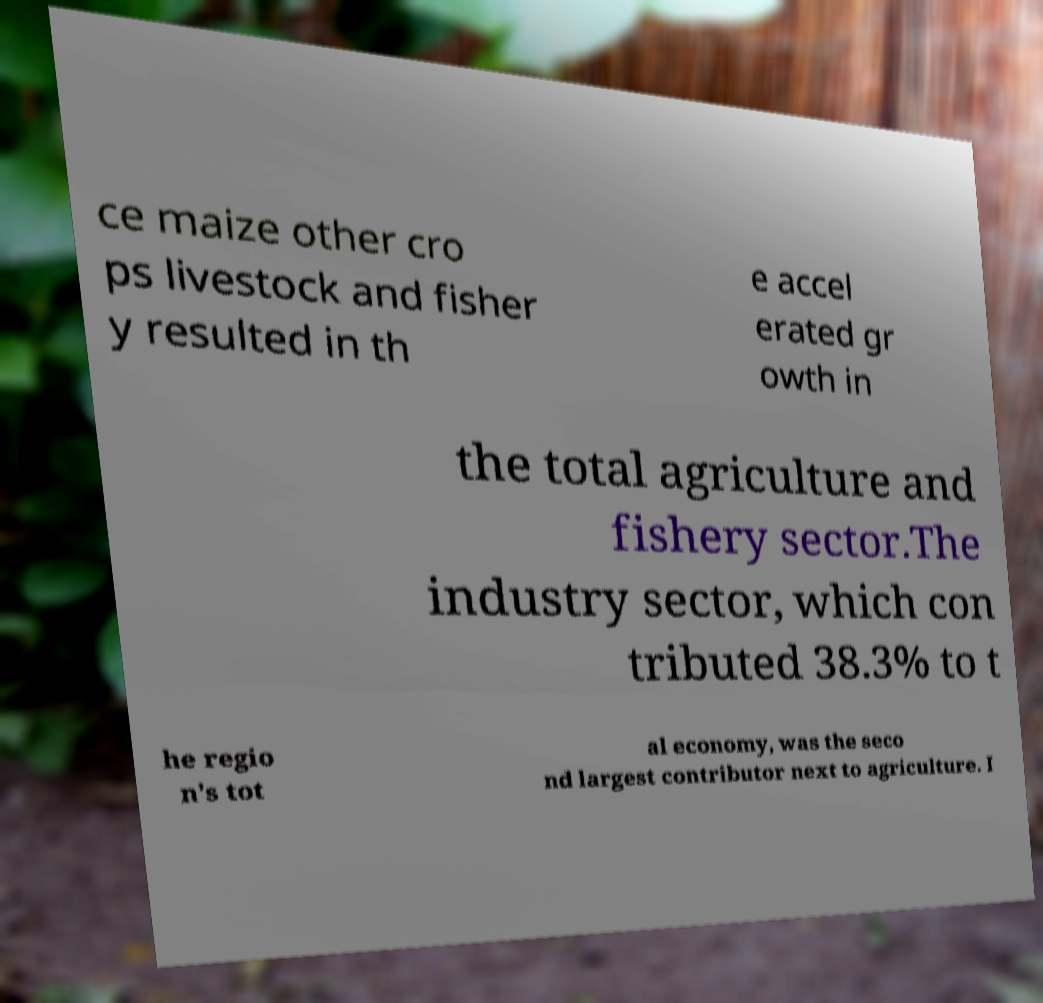For documentation purposes, I need the text within this image transcribed. Could you provide that? ce maize other cro ps livestock and fisher y resulted in th e accel erated gr owth in the total agriculture and fishery sector.The industry sector, which con tributed 38.3% to t he regio n's tot al economy, was the seco nd largest contributor next to agriculture. I 